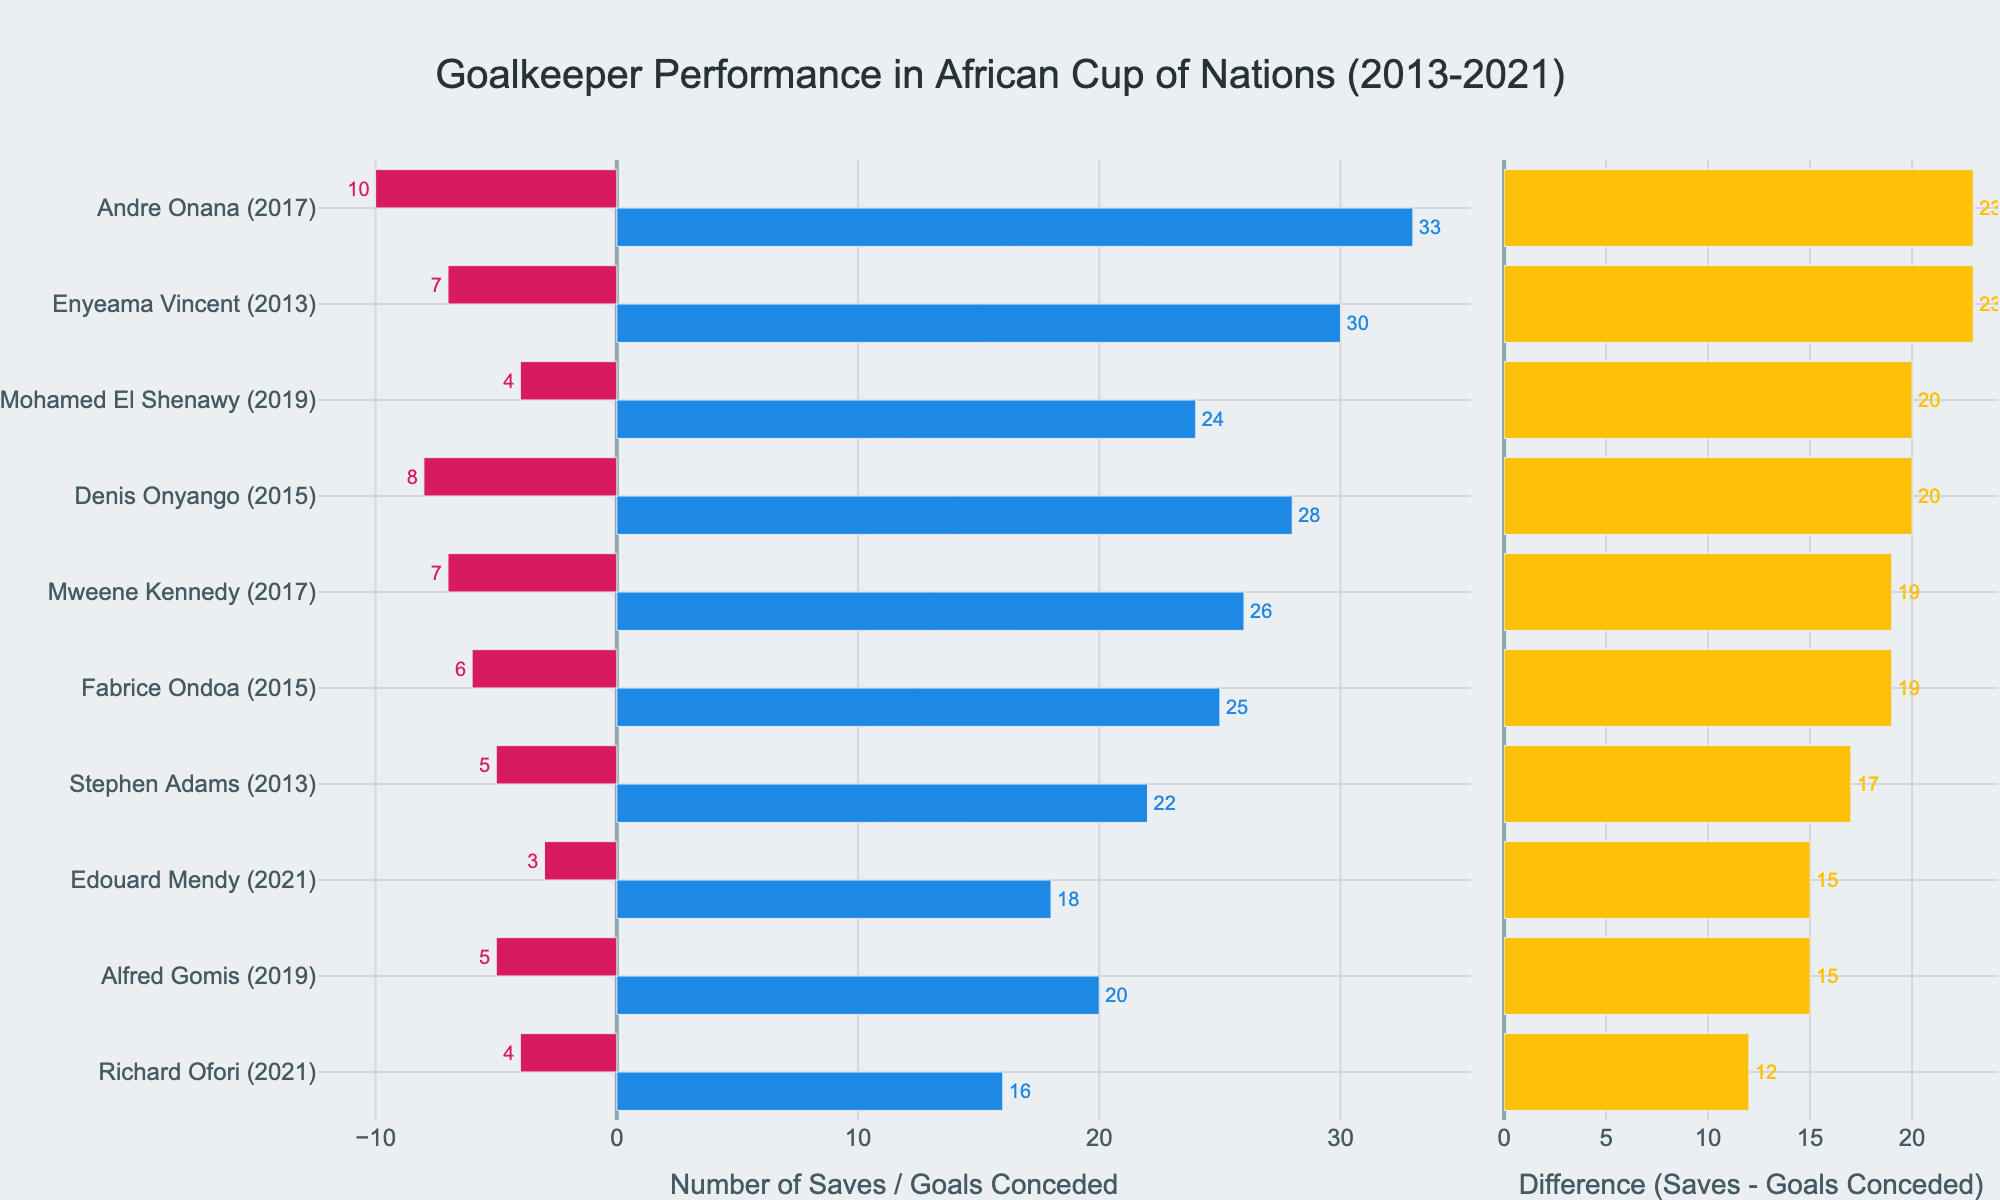Which goalkeeper had the highest number of saves in a single year? According to the chart, Enyeama Vincent from Nigeria had the highest number of saves, with 30 in 2013.
Answer: Enyeama Vincent What is the difference in saves between Andre Onana and Edouard Mendy? Andre Onana made 33 saves in 2017, while Edouard Mendy made 18 saves in 2021. The difference in saves is 33 - 18 = 15.
Answer: 15 Which goalkeeper conceded the fewest number of goals, and how many did they concede? The chart shows that Edouard Mendy from Senegal conceded the fewest number of goals, with 3 goals in 2021.
Answer: Edouard Mendy, 3 Compare the performance of Stephen Adams and Richard Ofori based on their difference in saves and goals conceded. Stephen Adams had a difference of 22 saves - 5 goals conceded = 17. Richard Ofori had a difference of 16 saves - 4 goals conceded = 12. Based on the difference, Stephen Adams performed better with a higher difference of 17 compared to Richard Ofori's 12.
Answer: Stephen Adams performed better Who had a higher number of goals conceded: Fabrice Ondoa or Denis Onyango? Fabrice Ondoa conceded 6 goals in 2015, while Denis Onyango conceded 8 goals in 2015. Thus, Denis Onyango had a higher number of goals conceded.
Answer: Denis Onyango Which two goalkeepers had the same number of goals conceded but different years? The chart shows that Mohamed El Shenawy from Egypt (2019) and Fabrice Ondoa from Cameroon (2015) both conceded 6 goals but in different years.
Answer: Mohamed El Shenawy and Fabrice Ondoa What was the total number of saves made by goalkeepers in 2021? In 2021, Edouard Mendy made 18 saves, and Richard Ofori made 16 saves. The total number of saves in 2021 is 18 + 16 = 34.
Answer: 34 What is the average difference in saves and goals conceded for the goalkeepers in the years given? To find the average difference, sum up the differences and divide by the number of goalkeepers. Differences are: 17 (Stephen Adams) + 23 (Enyeama Vincent) + 19 (Fabrice Ondoa) + 20 (Denis Onyango) + 23 (Andre Onana) + 19 (Mweene Kennedy) + 20 (Mohamed El Shenawy) + 15 (Alfred Gomis) + 15 (Edouard Mendy) + 12 (Richard Ofori) = 183. There are 10 goalkeepers, so the average difference is 183/10 = 18.3.
Answer: 18.3 